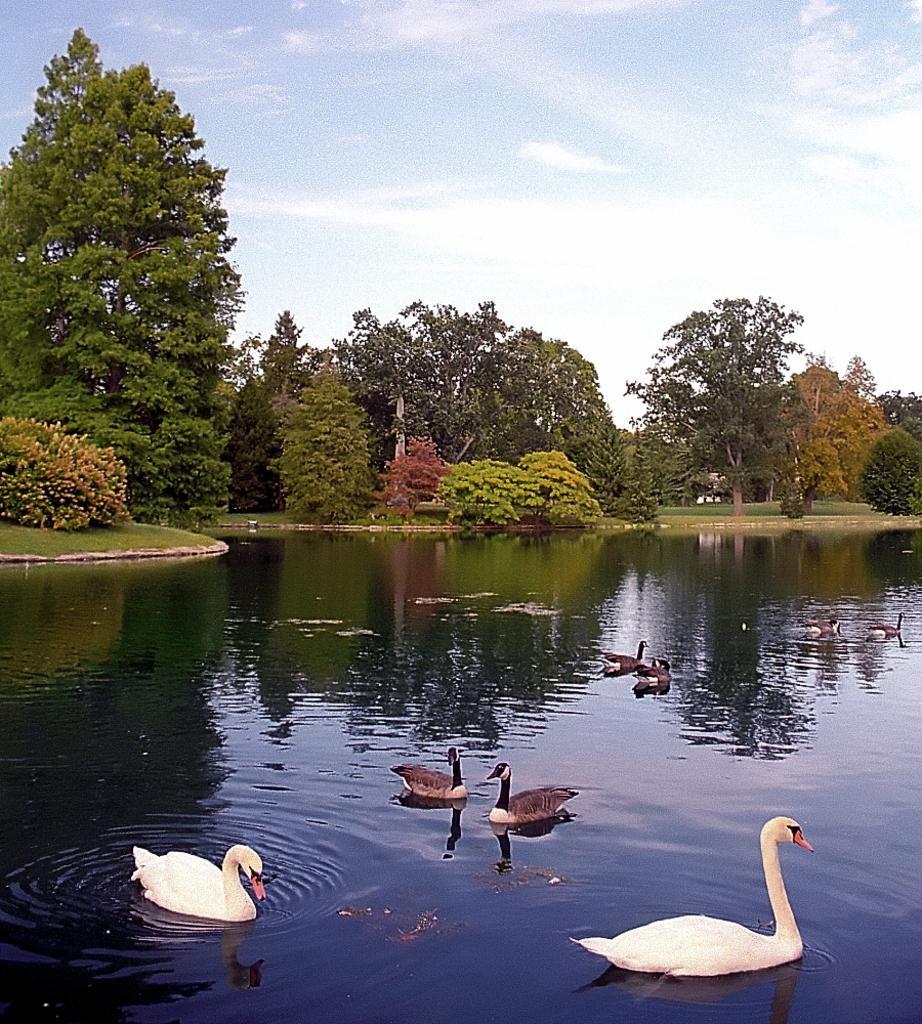In one or two sentences, can you explain what this image depicts? In this picture we can see birds on the water. In the background of the image we can see grass, trees and sky. 